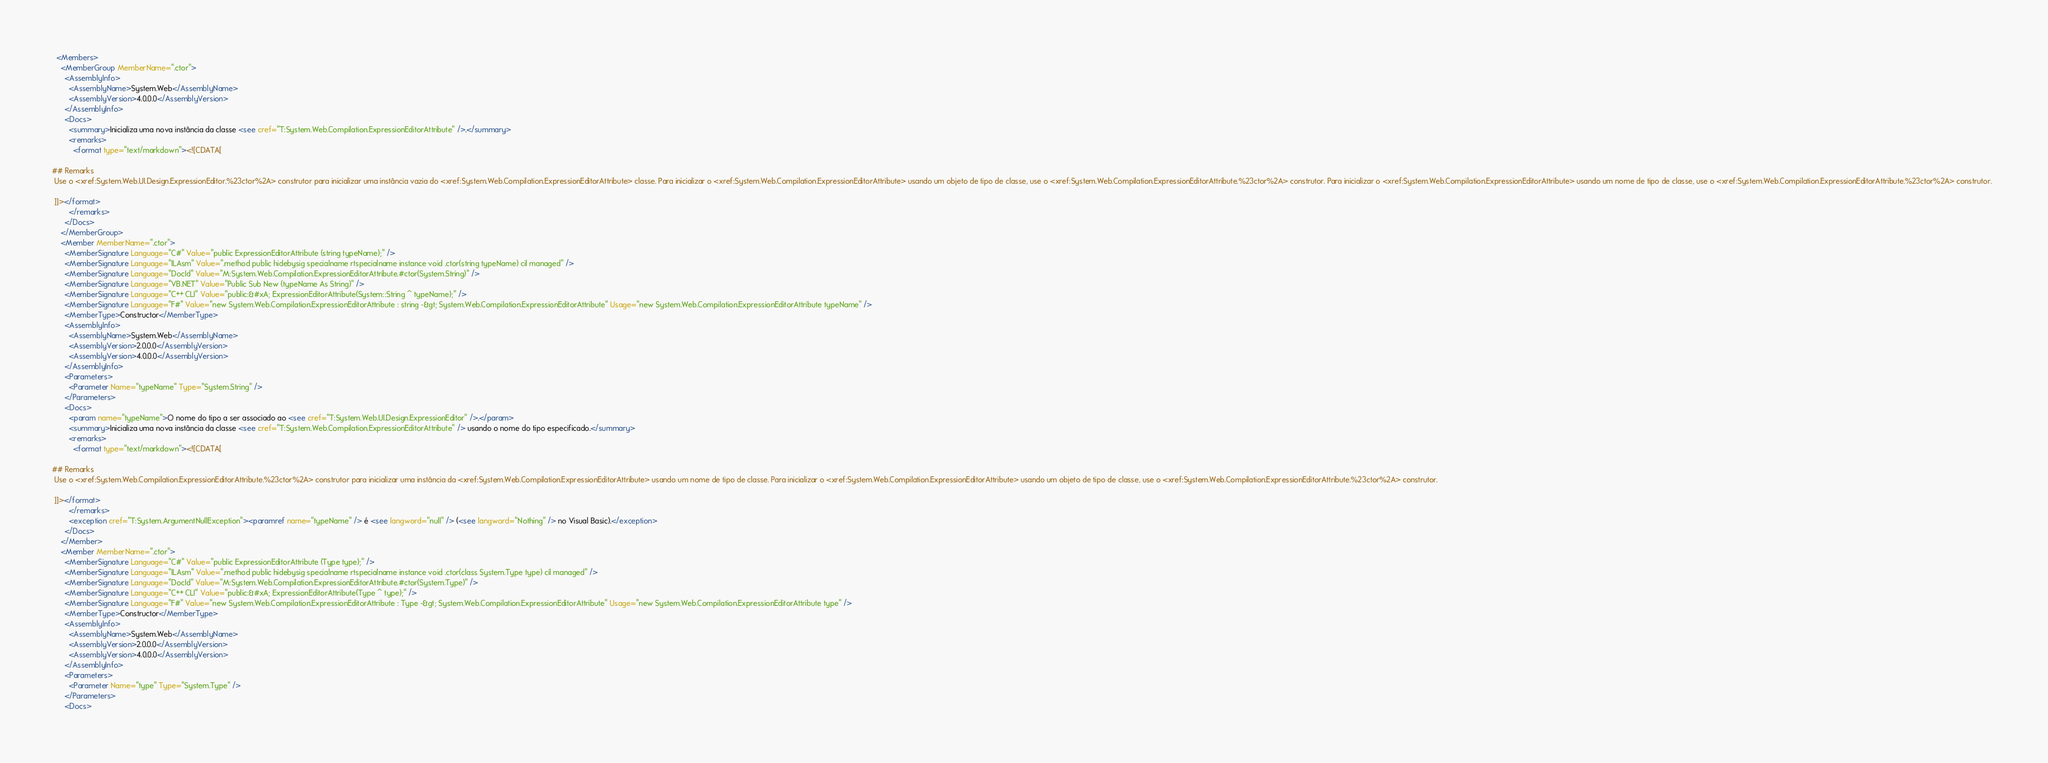<code> <loc_0><loc_0><loc_500><loc_500><_XML_>  <Members>
    <MemberGroup MemberName=".ctor">
      <AssemblyInfo>
        <AssemblyName>System.Web</AssemblyName>
        <AssemblyVersion>4.0.0.0</AssemblyVersion>
      </AssemblyInfo>
      <Docs>
        <summary>Inicializa uma nova instância da classe <see cref="T:System.Web.Compilation.ExpressionEditorAttribute" />.</summary>
        <remarks>
          <format type="text/markdown"><![CDATA[  
  
## Remarks  
 Use o <xref:System.Web.UI.Design.ExpressionEditor.%23ctor%2A> construtor para inicializar uma instância vazia do <xref:System.Web.Compilation.ExpressionEditorAttribute> classe. Para inicializar o <xref:System.Web.Compilation.ExpressionEditorAttribute> usando um objeto de tipo de classe, use o <xref:System.Web.Compilation.ExpressionEditorAttribute.%23ctor%2A> construtor. Para inicializar o <xref:System.Web.Compilation.ExpressionEditorAttribute> usando um nome de tipo de classe, use o <xref:System.Web.Compilation.ExpressionEditorAttribute.%23ctor%2A> construtor.  
  
 ]]></format>
        </remarks>
      </Docs>
    </MemberGroup>
    <Member MemberName=".ctor">
      <MemberSignature Language="C#" Value="public ExpressionEditorAttribute (string typeName);" />
      <MemberSignature Language="ILAsm" Value=".method public hidebysig specialname rtspecialname instance void .ctor(string typeName) cil managed" />
      <MemberSignature Language="DocId" Value="M:System.Web.Compilation.ExpressionEditorAttribute.#ctor(System.String)" />
      <MemberSignature Language="VB.NET" Value="Public Sub New (typeName As String)" />
      <MemberSignature Language="C++ CLI" Value="public:&#xA; ExpressionEditorAttribute(System::String ^ typeName);" />
      <MemberSignature Language="F#" Value="new System.Web.Compilation.ExpressionEditorAttribute : string -&gt; System.Web.Compilation.ExpressionEditorAttribute" Usage="new System.Web.Compilation.ExpressionEditorAttribute typeName" />
      <MemberType>Constructor</MemberType>
      <AssemblyInfo>
        <AssemblyName>System.Web</AssemblyName>
        <AssemblyVersion>2.0.0.0</AssemblyVersion>
        <AssemblyVersion>4.0.0.0</AssemblyVersion>
      </AssemblyInfo>
      <Parameters>
        <Parameter Name="typeName" Type="System.String" />
      </Parameters>
      <Docs>
        <param name="typeName">O nome do tipo a ser associado ao <see cref="T:System.Web.UI.Design.ExpressionEditor" />.</param>
        <summary>Inicializa uma nova instância da classe <see cref="T:System.Web.Compilation.ExpressionEditorAttribute" /> usando o nome do tipo especificado.</summary>
        <remarks>
          <format type="text/markdown"><![CDATA[  
  
## Remarks  
 Use o <xref:System.Web.Compilation.ExpressionEditorAttribute.%23ctor%2A> construtor para inicializar uma instância da <xref:System.Web.Compilation.ExpressionEditorAttribute> usando um nome de tipo de classe. Para inicializar o <xref:System.Web.Compilation.ExpressionEditorAttribute> usando um objeto de tipo de classe, use o <xref:System.Web.Compilation.ExpressionEditorAttribute.%23ctor%2A> construtor.  
  
 ]]></format>
        </remarks>
        <exception cref="T:System.ArgumentNullException"><paramref name="typeName" /> é <see langword="null" /> (<see langword="Nothing" /> no Visual Basic).</exception>
      </Docs>
    </Member>
    <Member MemberName=".ctor">
      <MemberSignature Language="C#" Value="public ExpressionEditorAttribute (Type type);" />
      <MemberSignature Language="ILAsm" Value=".method public hidebysig specialname rtspecialname instance void .ctor(class System.Type type) cil managed" />
      <MemberSignature Language="DocId" Value="M:System.Web.Compilation.ExpressionEditorAttribute.#ctor(System.Type)" />
      <MemberSignature Language="C++ CLI" Value="public:&#xA; ExpressionEditorAttribute(Type ^ type);" />
      <MemberSignature Language="F#" Value="new System.Web.Compilation.ExpressionEditorAttribute : Type -&gt; System.Web.Compilation.ExpressionEditorAttribute" Usage="new System.Web.Compilation.ExpressionEditorAttribute type" />
      <MemberType>Constructor</MemberType>
      <AssemblyInfo>
        <AssemblyName>System.Web</AssemblyName>
        <AssemblyVersion>2.0.0.0</AssemblyVersion>
        <AssemblyVersion>4.0.0.0</AssemblyVersion>
      </AssemblyInfo>
      <Parameters>
        <Parameter Name="type" Type="System.Type" />
      </Parameters>
      <Docs></code> 